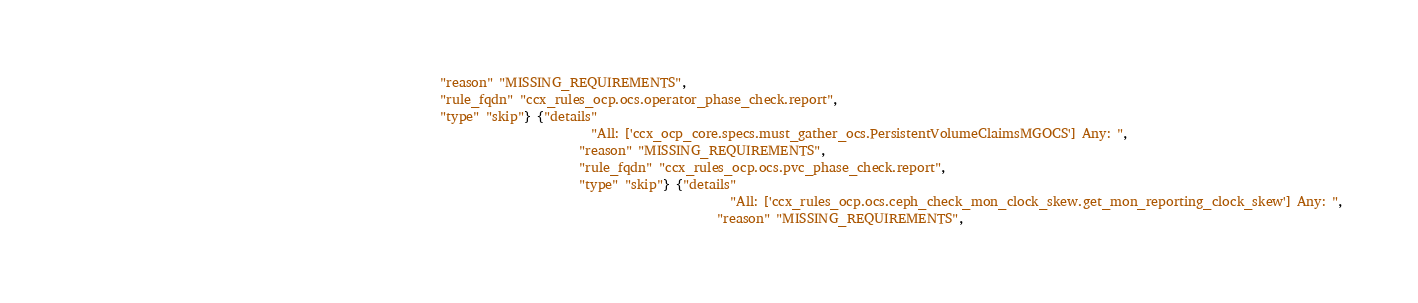<code> <loc_0><loc_0><loc_500><loc_500><_Clojure_>                                                          "reason" "MISSING_REQUIREMENTS",
                                                          "rule_fqdn" "ccx_rules_ocp.ocs.operator_phase_check.report",
                                                          "type" "skip"} {"details"
                                                                                  "All: ['ccx_ocp_core.specs.must_gather_ocs.PersistentVolumeClaimsMGOCS'] Any: ",
                                                                                "reason" "MISSING_REQUIREMENTS",
                                                                                "rule_fqdn" "ccx_rules_ocp.ocs.pvc_phase_check.report",
                                                                                "type" "skip"} {"details"
                                                                                                        "All: ['ccx_rules_ocp.ocs.ceph_check_mon_clock_skew.get_mon_reporting_clock_skew'] Any: ",
                                                                                                      "reason" "MISSING_REQUIREMENTS",</code> 